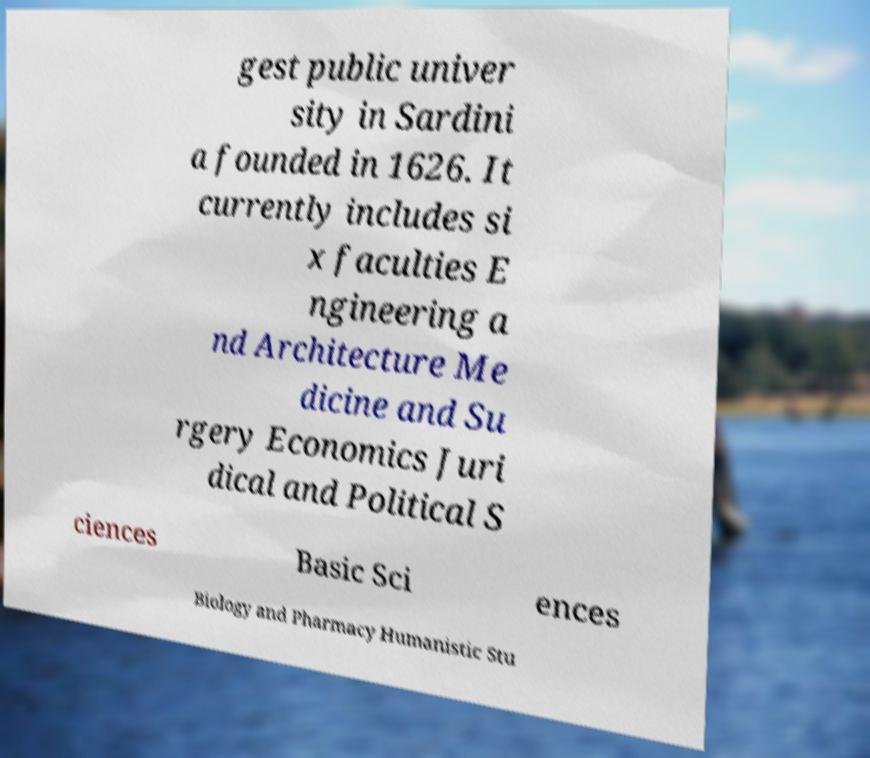Could you extract and type out the text from this image? gest public univer sity in Sardini a founded in 1626. It currently includes si x faculties E ngineering a nd Architecture Me dicine and Su rgery Economics Juri dical and Political S ciences Basic Sci ences Biology and Pharmacy Humanistic Stu 